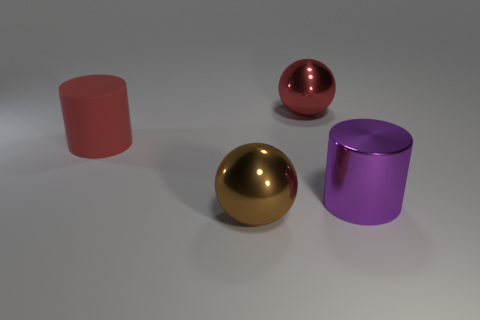Are any cylinders visible?
Your answer should be very brief. Yes. Are there any cylinders left of the shiny cylinder?
Ensure brevity in your answer.  Yes. What is the material of the brown thing that is the same shape as the red metal object?
Ensure brevity in your answer.  Metal. Are there any other things that are the same material as the big red cylinder?
Your answer should be compact. No. What number of other things are there of the same shape as the large purple metal thing?
Give a very brief answer. 1. How many large brown metal balls are to the left of the large ball that is in front of the metallic object that is behind the large metal cylinder?
Your response must be concise. 0. What number of other large things are the same shape as the brown thing?
Offer a terse response. 1. Does the metal object behind the metal cylinder have the same color as the large rubber object?
Keep it short and to the point. Yes. There is a large red thing on the right side of the brown metal sphere in front of the metal sphere that is behind the big purple object; what shape is it?
Your response must be concise. Sphere. Are there any metallic things that have the same size as the brown metal ball?
Your answer should be compact. Yes. 